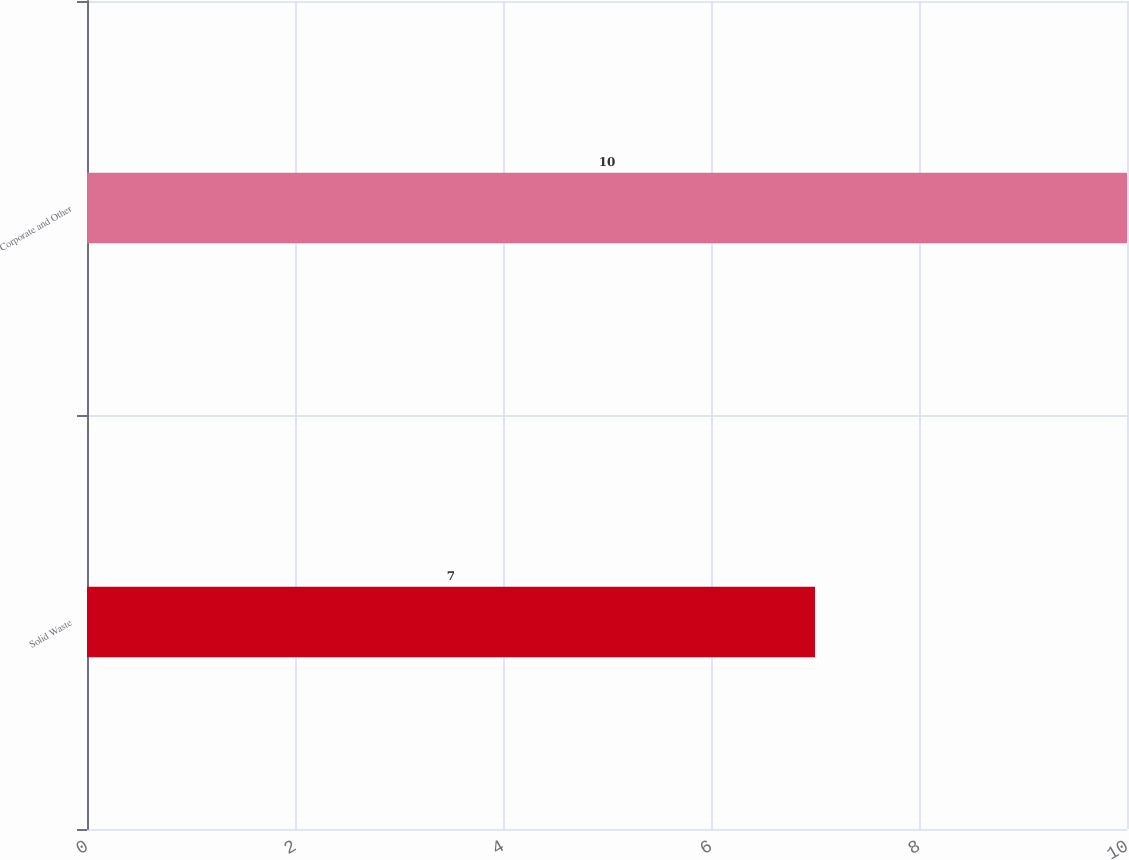<chart> <loc_0><loc_0><loc_500><loc_500><bar_chart><fcel>Solid Waste<fcel>Corporate and Other<nl><fcel>7<fcel>10<nl></chart> 